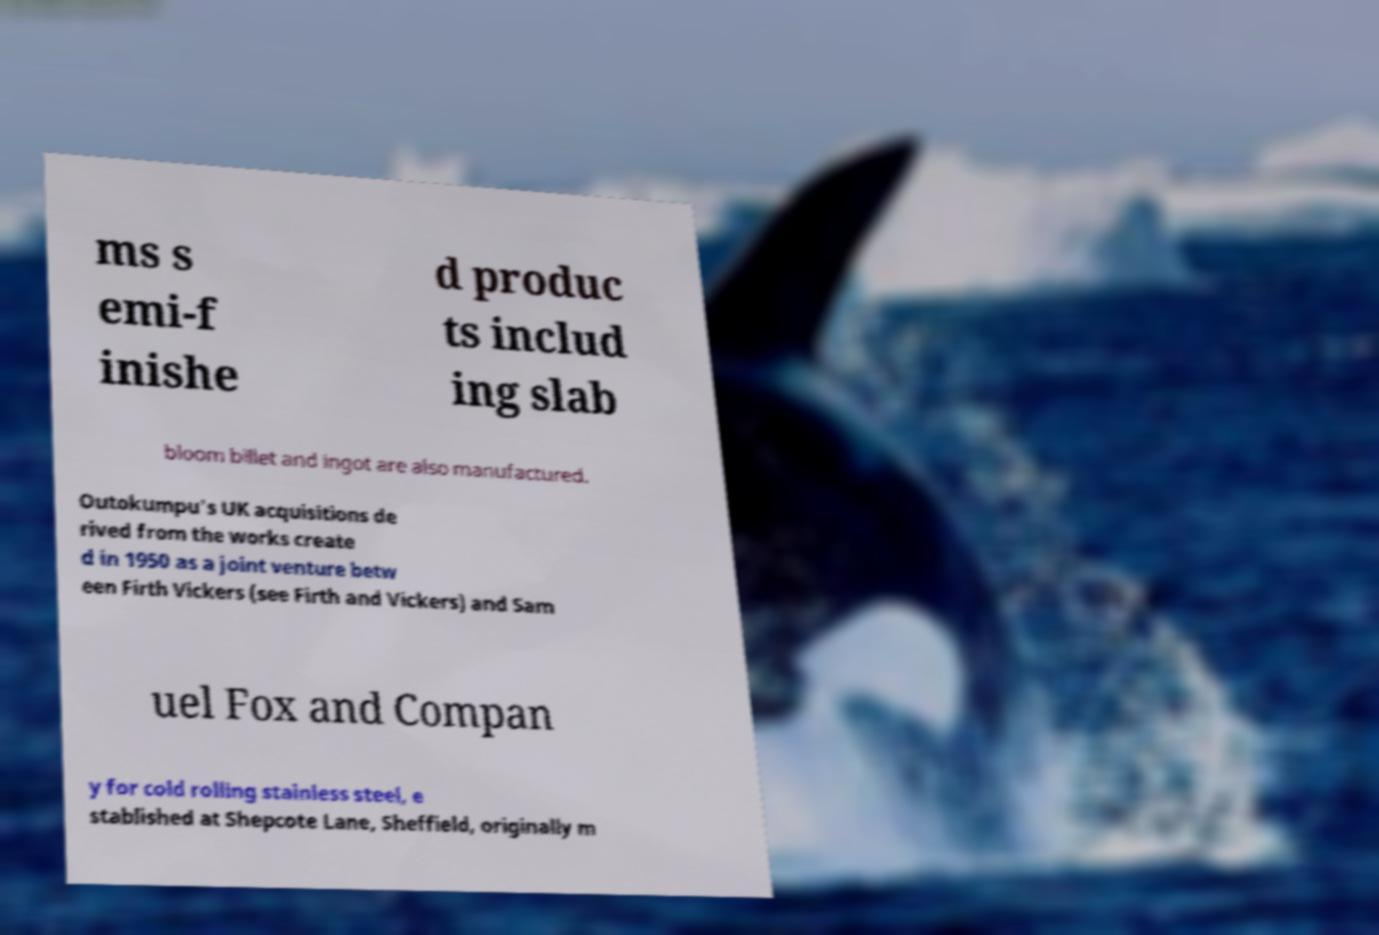Can you read and provide the text displayed in the image?This photo seems to have some interesting text. Can you extract and type it out for me? ms s emi-f inishe d produc ts includ ing slab bloom billet and ingot are also manufactured. Outokumpu's UK acquisitions de rived from the works create d in 1950 as a joint venture betw een Firth Vickers (see Firth and Vickers) and Sam uel Fox and Compan y for cold rolling stainless steel, e stablished at Shepcote Lane, Sheffield, originally m 